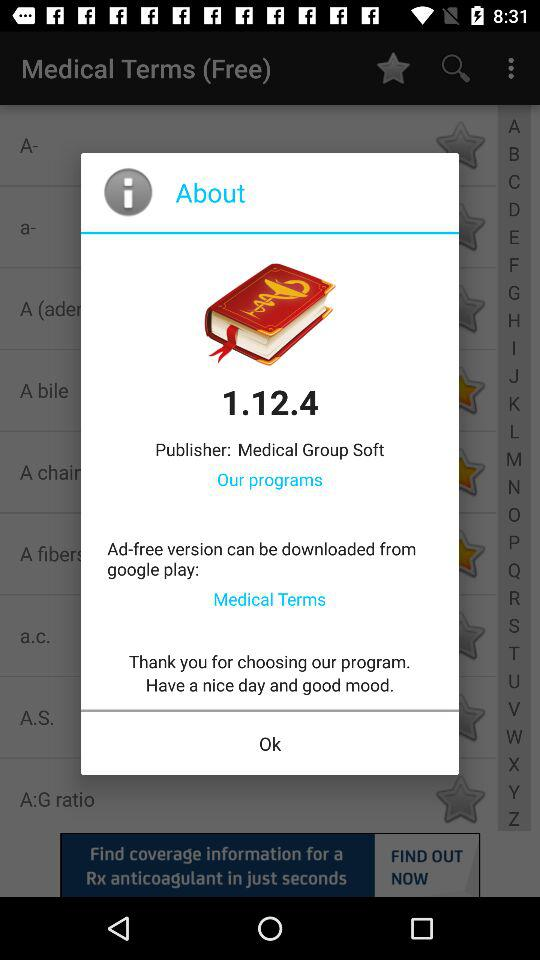How many versions of the app are available?
Answer the question using a single word or phrase. 1.12.4 